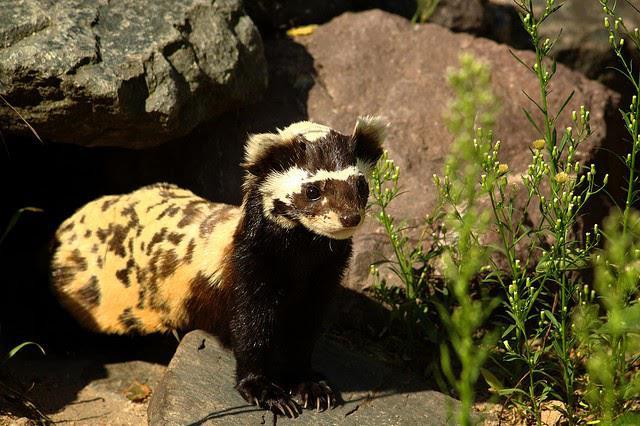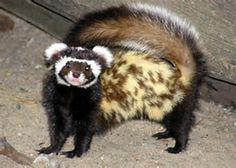The first image is the image on the left, the second image is the image on the right. Given the left and right images, does the statement "The right image features one ferret with spotted fur and a tail that curves inward over its back, and the left image features an animal with its front paws on a rock and its body turned rightward." hold true? Answer yes or no. Yes. The first image is the image on the left, the second image is the image on the right. For the images displayed, is the sentence "The left and right image contains the same number of mustelids facing opposite directions." factually correct? Answer yes or no. Yes. 